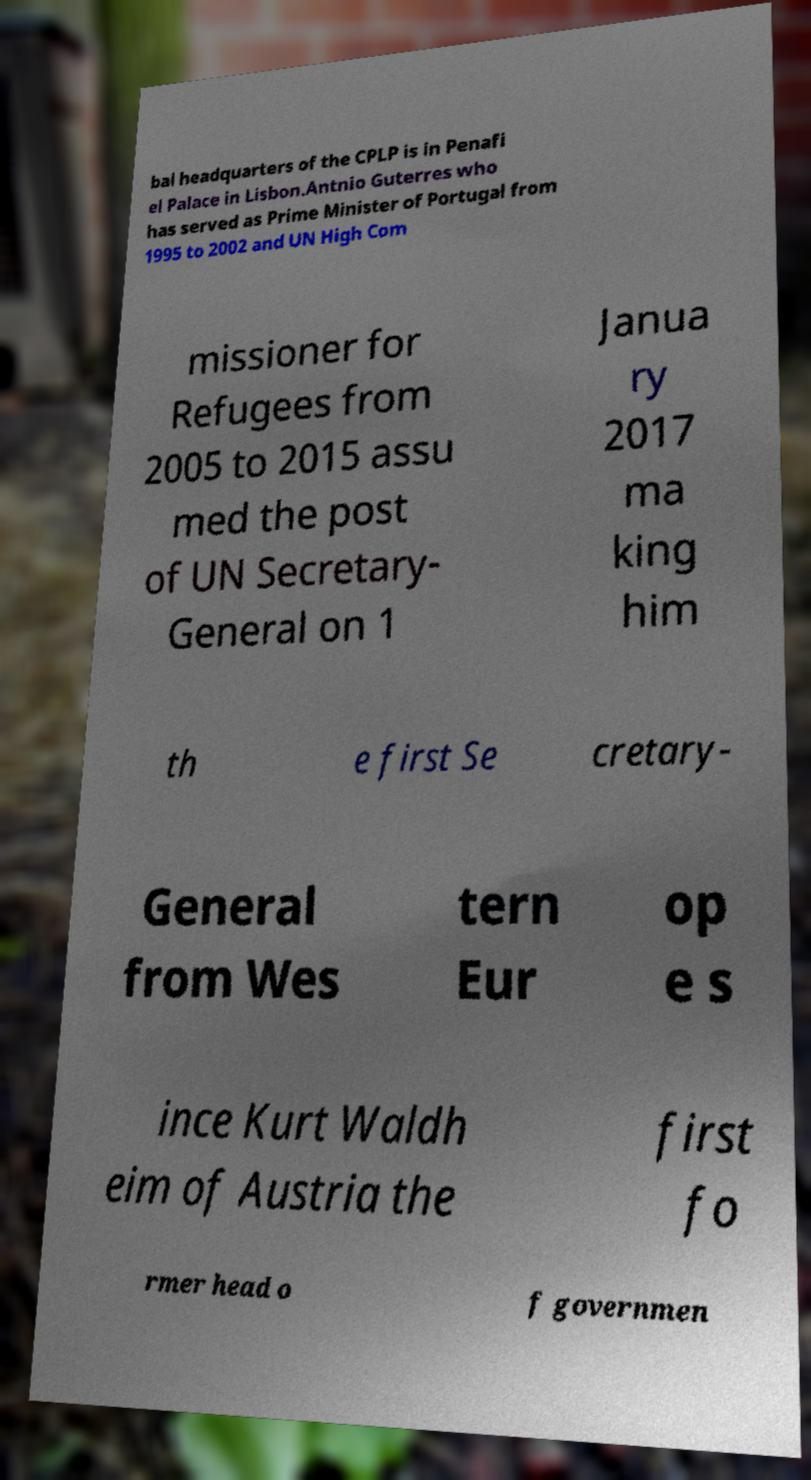For documentation purposes, I need the text within this image transcribed. Could you provide that? bal headquarters of the CPLP is in Penafi el Palace in Lisbon.Antnio Guterres who has served as Prime Minister of Portugal from 1995 to 2002 and UN High Com missioner for Refugees from 2005 to 2015 assu med the post of UN Secretary- General on 1 Janua ry 2017 ma king him th e first Se cretary- General from Wes tern Eur op e s ince Kurt Waldh eim of Austria the first fo rmer head o f governmen 